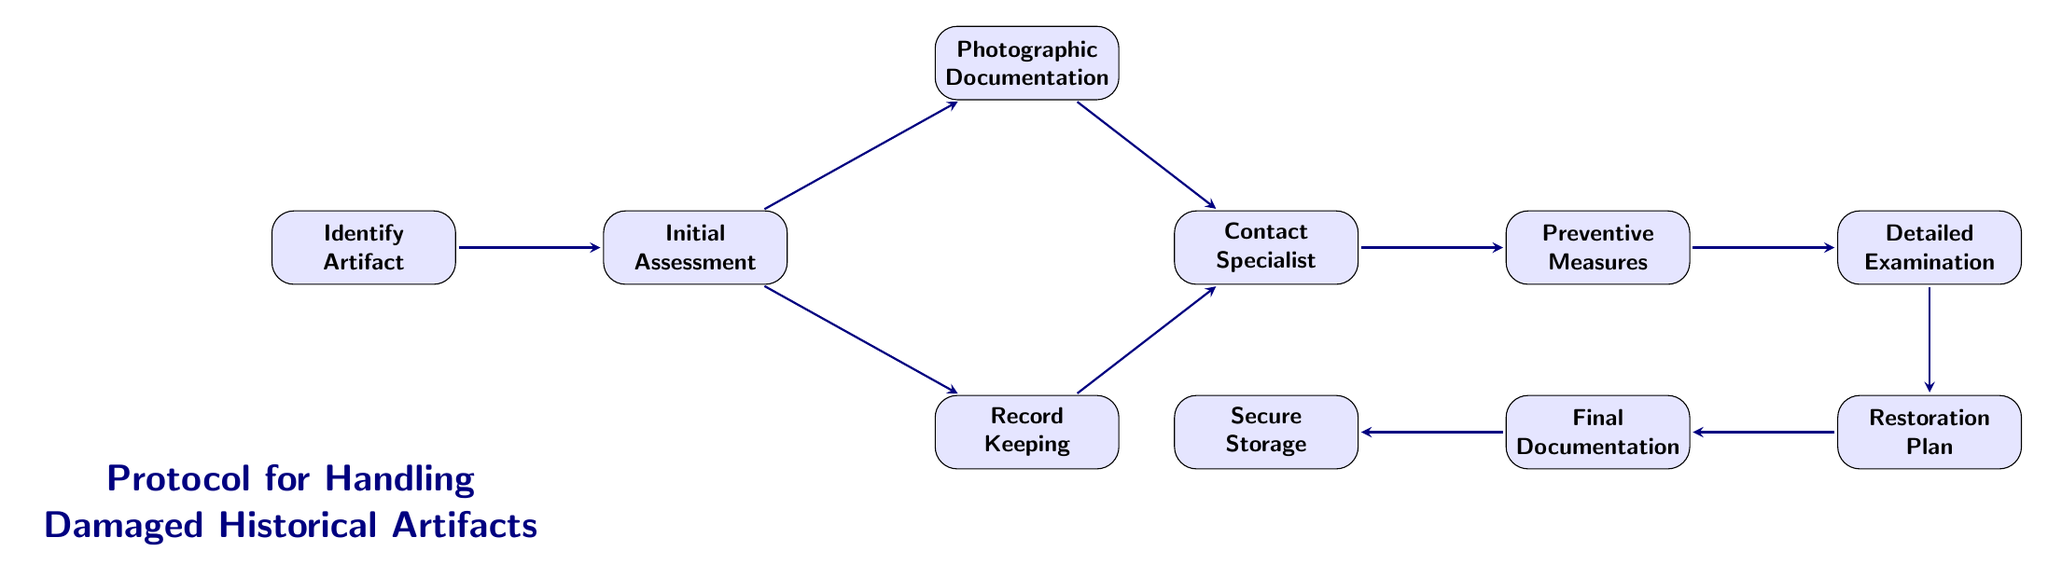What is the first step in the protocol? The protocol begins with the "Identify Artifact" step. This is directly indicated as the first node in the flow chart.
Answer: Identify Artifact How many nodes are in the diagram? The diagram consists of a total of 10 nodes, each representing a step in the process for handling damaged historical artifacts.
Answer: 10 Which steps follow the "Initial Assessment"? From "Initial Assessment," the next steps are "Photographic Documentation" and "Record Keeping," which are connected directly to it via arrows.
Answer: Photographic Documentation, Record Keeping What must be done after contacting a specialist? After contacting a specialist, the next step is to implement "Preventive Measures," which is the subsequent node following "Contact Specialist."
Answer: Preventive Measures Which step involves updating records? The "Final Documentation" step is responsible for updating records with the findings and restoration plan, following the "Restoration Plan" step.
Answer: Final Documentation What is the purpose of "Preventive Measures"? "Preventive Measures" aims to apply temporary measures to prevent further damage to the artifact, as noted in the description for that node.
Answer: Apply temporary measures What nodes lead to "Detailed Examination"? The node "Contact Specialist" leads to "Detailed Examination" as the next step, which follows the completion of preventive actions.
Answer: Contact Specialist What comes after the "Restoration Plan"? The step that comes after the "Restoration Plan" is "Final Documentation," which focuses on updating records based on the restoration plan developed in the previous step.
Answer: Final Documentation Which steps involve documentation? The steps that involve documentation are "Photographic Documentation" and "Final Documentation," which focus on recording different aspects of the artifact handling process.
Answer: Photographic Documentation, Final Documentation 